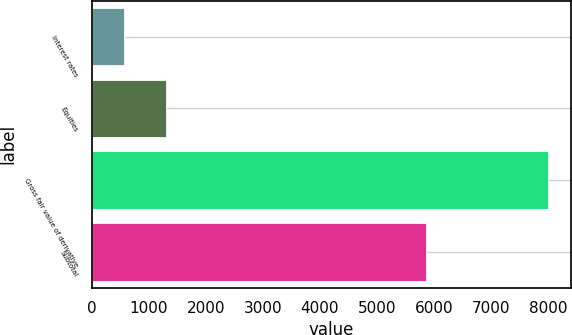<chart> <loc_0><loc_0><loc_500><loc_500><bar_chart><fcel>Interest rates<fcel>Equities<fcel>Gross fair value of derivative<fcel>Subtotal<nl><fcel>560<fcel>1304.9<fcel>8009<fcel>5870<nl></chart> 